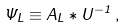Convert formula to latex. <formula><loc_0><loc_0><loc_500><loc_500>\Psi _ { L } \equiv A _ { L } \ast U ^ { - 1 } \, ,</formula> 